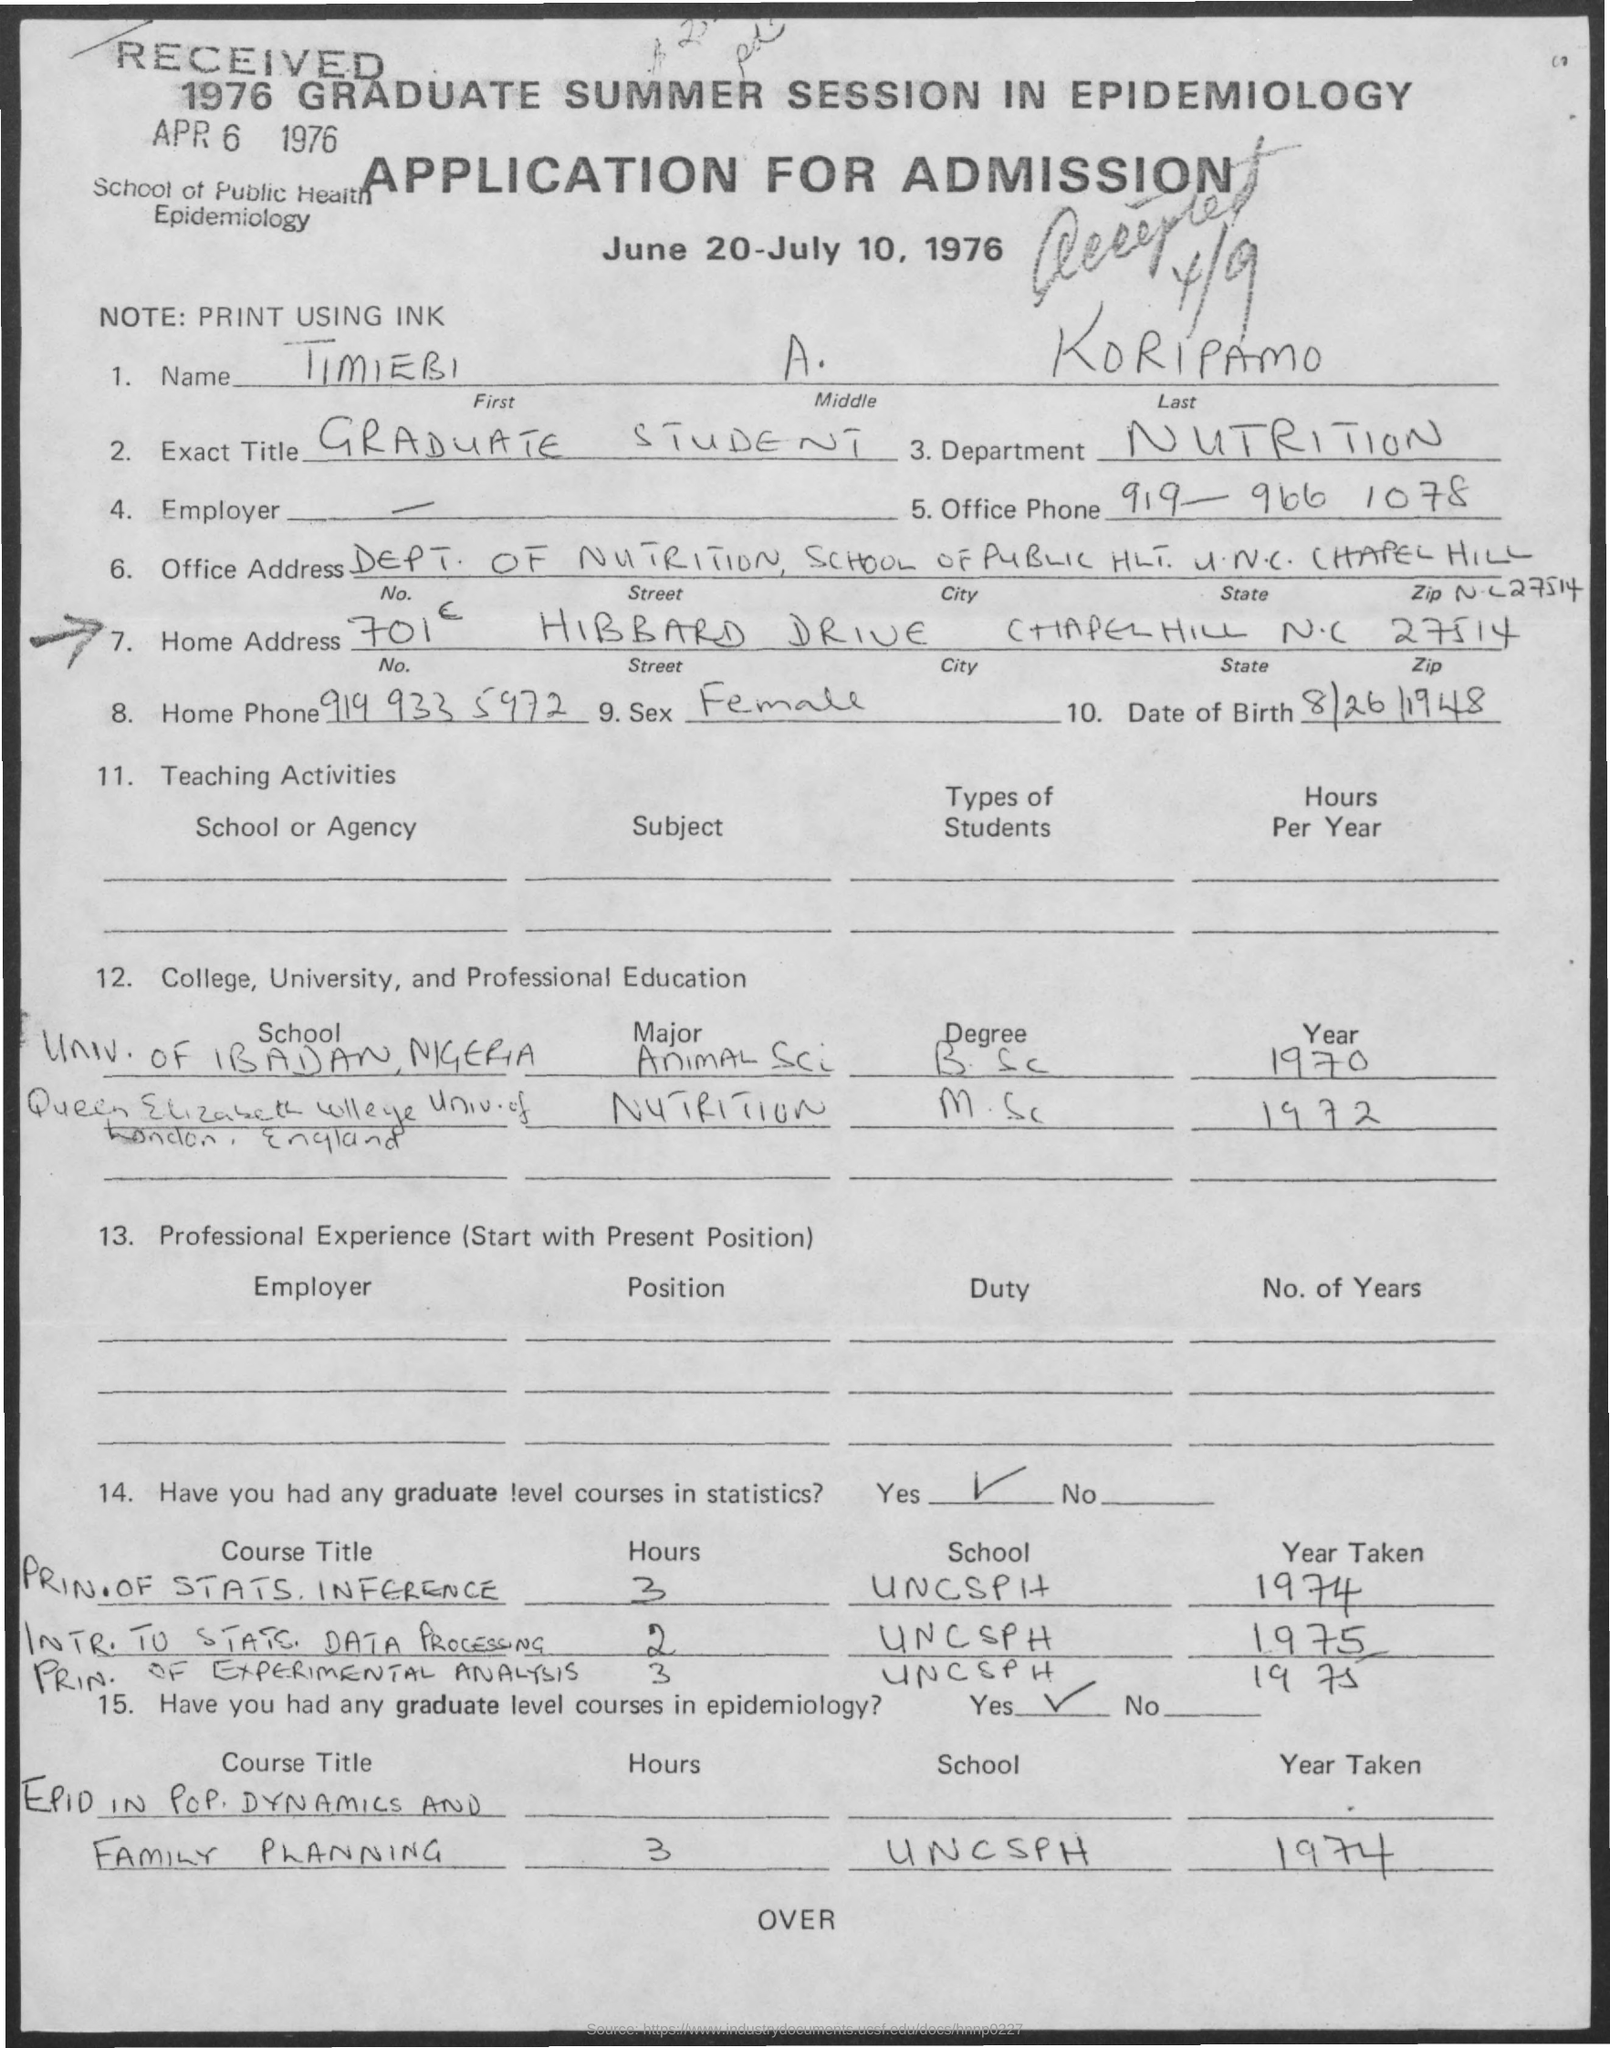What is the Title of the document?
Give a very brief answer. APPLICATION FOR ADMISSION. What is the First Name?
Your answer should be very brief. TIMIEBI. What is the Middle Name?
Make the answer very short. A. What is the Last Name?
Your answer should be very brief. Koripamo. What is the Exact Title?
Offer a very short reply. Graduate Student. What is the Department?
Offer a very short reply. NUTRITION. What is the Office Phone?
Your answer should be compact. 919-966 1078. What is the City?
Your answer should be compact. Chapel Hill. What is the State?
Your answer should be very brief. N.C. What is the Date of Birth?
Your answer should be very brief. 8/26/1948. 